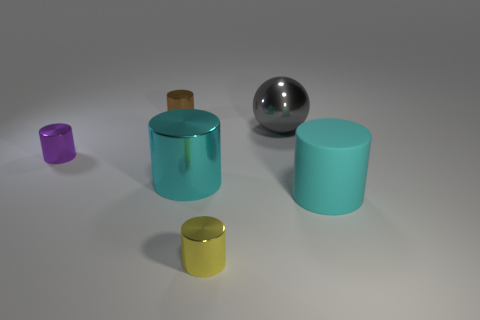Is the number of small metallic things on the left side of the gray sphere the same as the number of brown things that are on the left side of the purple metallic cylinder?
Your answer should be very brief. No. There is a small thing that is to the right of the tiny purple metal cylinder and in front of the gray object; what material is it?
Provide a succinct answer. Metal. There is a brown shiny thing; is its size the same as the metal thing that is right of the tiny yellow cylinder?
Provide a short and direct response. No. What number of other objects are the same color as the large rubber object?
Keep it short and to the point. 1. Are there more gray metal things on the right side of the tiny yellow metal thing than big metallic things?
Provide a short and direct response. No. What is the color of the object that is to the right of the large metallic thing that is to the right of the metal cylinder that is on the right side of the cyan metal cylinder?
Provide a short and direct response. Cyan. Is the material of the large gray sphere the same as the brown cylinder?
Keep it short and to the point. Yes. Is there a brown metallic cylinder that has the same size as the purple object?
Keep it short and to the point. Yes. There is a brown cylinder that is the same size as the yellow cylinder; what is it made of?
Provide a succinct answer. Metal. Are there any other tiny gray matte objects of the same shape as the gray thing?
Your answer should be compact. No. 